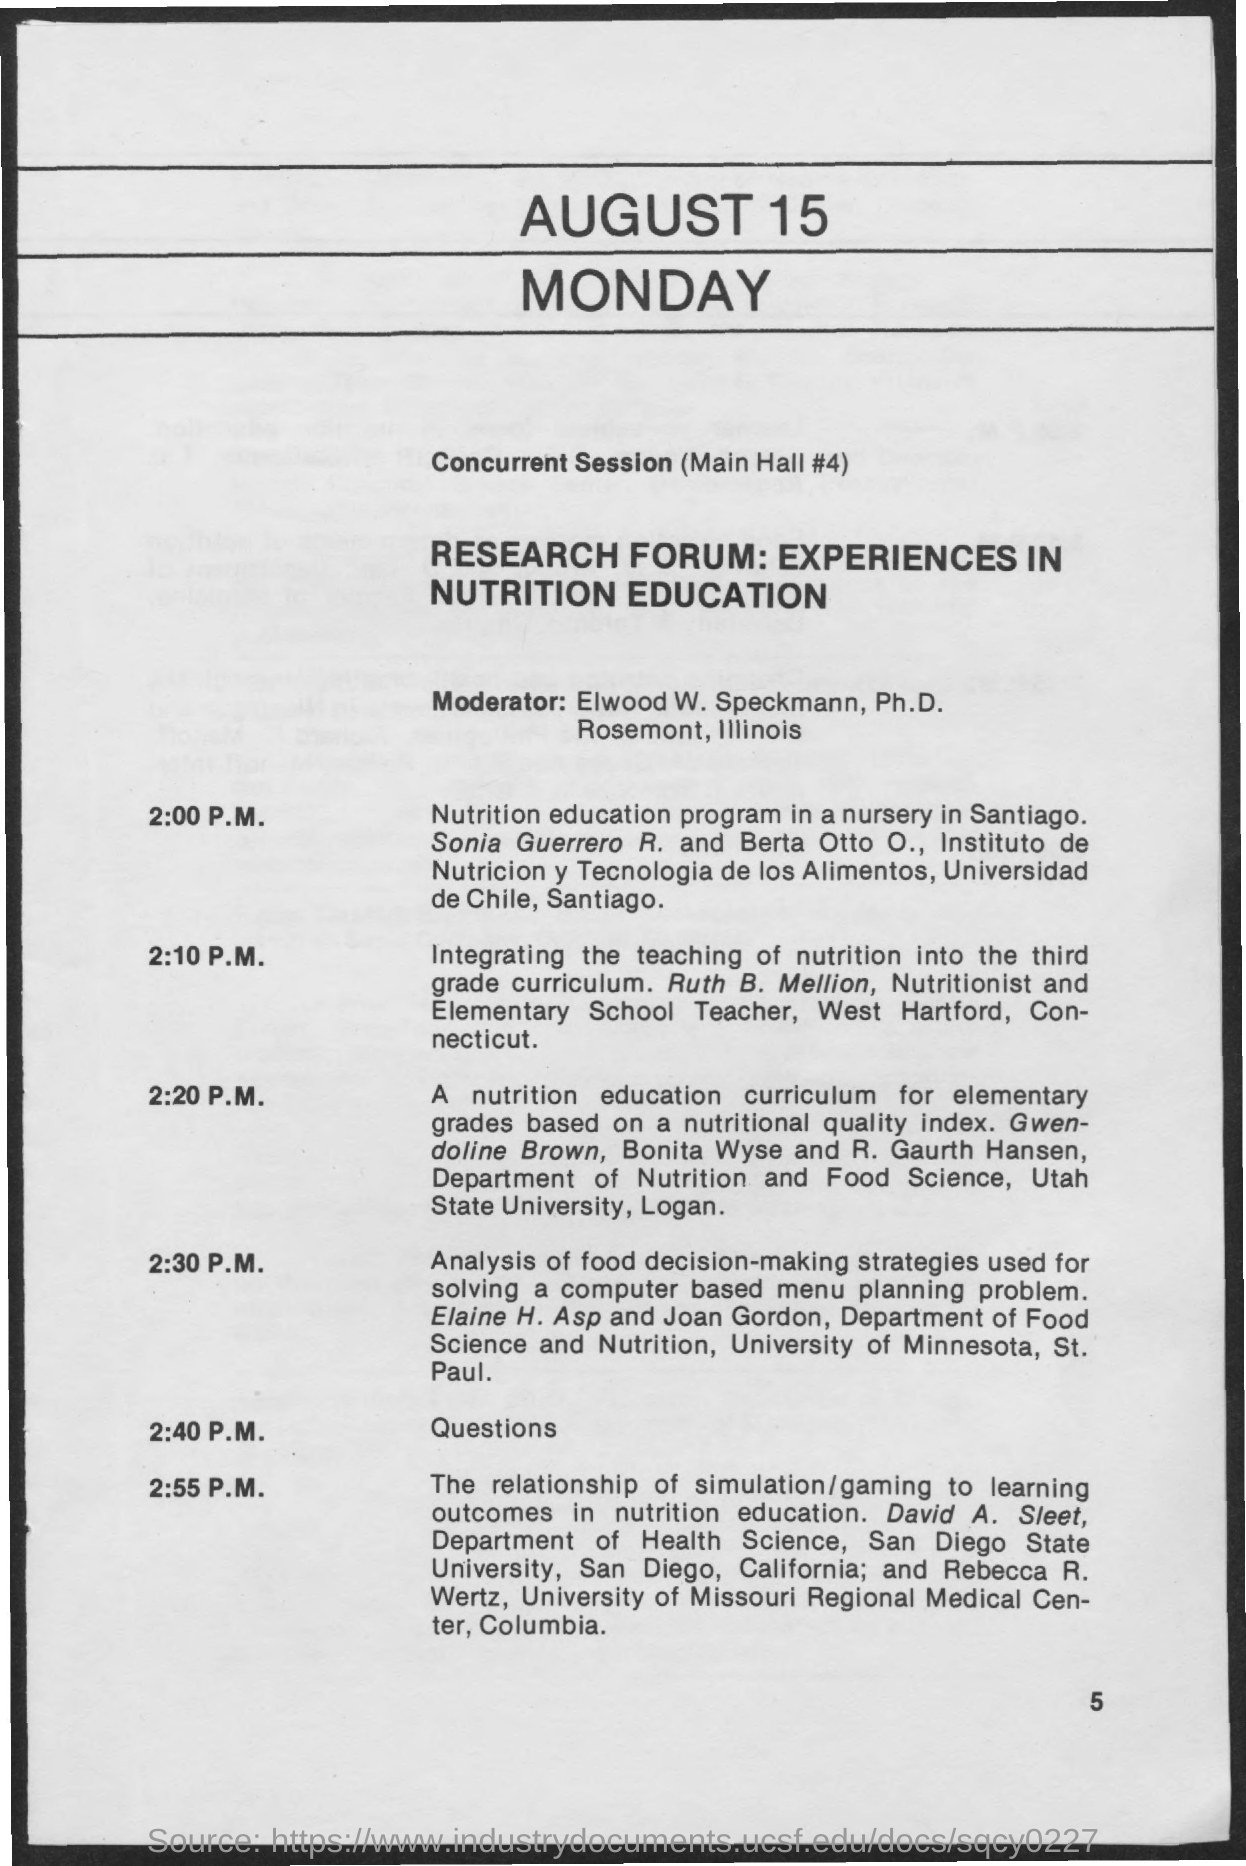Indicate a few pertinent items in this graphic. The questions session is scheduled for 2:40 P.M. The moderator for the sessions is Elwood W. Speckmann, Ph.D. The page number mentioned in this document is 5. The paper titled "Integrating the teaching of nutrition into third grade curriculum: A research forum" was presented by Ruth B. Mellion. 